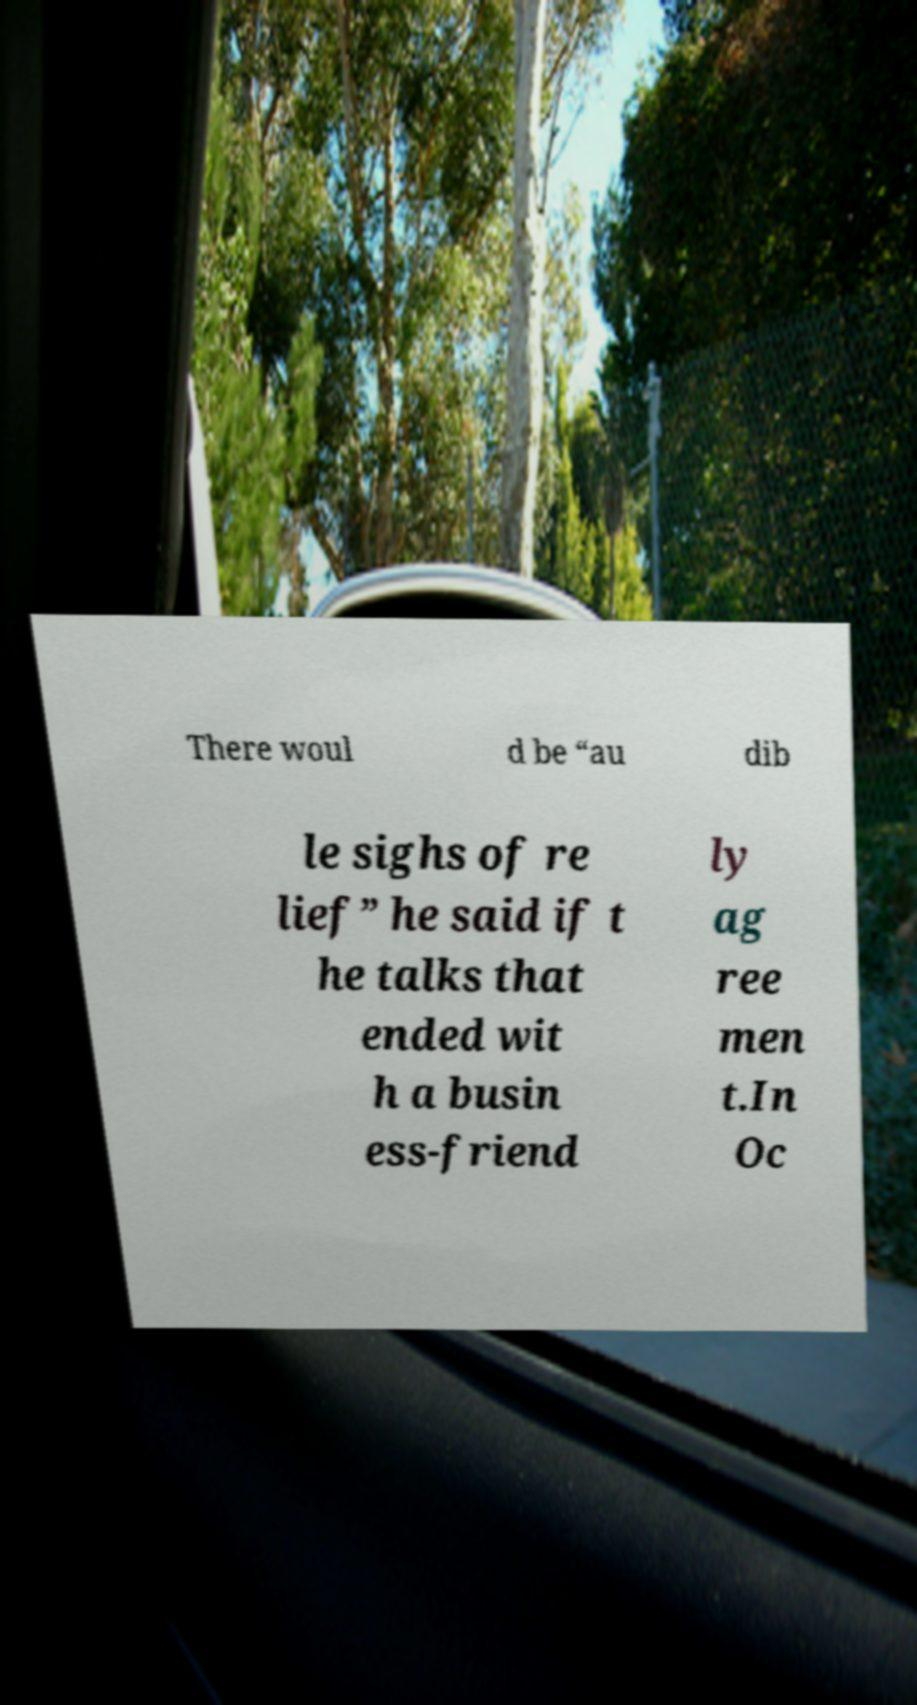For documentation purposes, I need the text within this image transcribed. Could you provide that? There woul d be “au dib le sighs of re lief” he said if t he talks that ended wit h a busin ess-friend ly ag ree men t.In Oc 